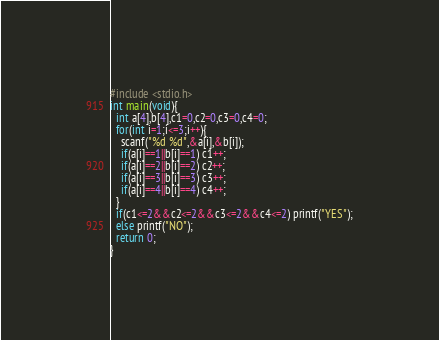Convert code to text. <code><loc_0><loc_0><loc_500><loc_500><_C_>#include <stdio.h>
int main(void){
  int a[4],b[4],c1=0,c2=0,c3=0,c4=0;
  for(int i=1;i<=3;i++){
    scanf("%d %d",&a[i],&b[i]);
    if(a[i]==1||b[i]==1) c1++;
    if(a[i]==2||b[i]==2) c2++;
    if(a[i]==3||b[i]==3) c3++;
    if(a[i]==4||b[i]==4) c4++;
  }
  if(c1<=2&&c2<=2&&c3<=2&&c4<=2) printf("YES");
  else printf("NO");
  return 0;
}</code> 